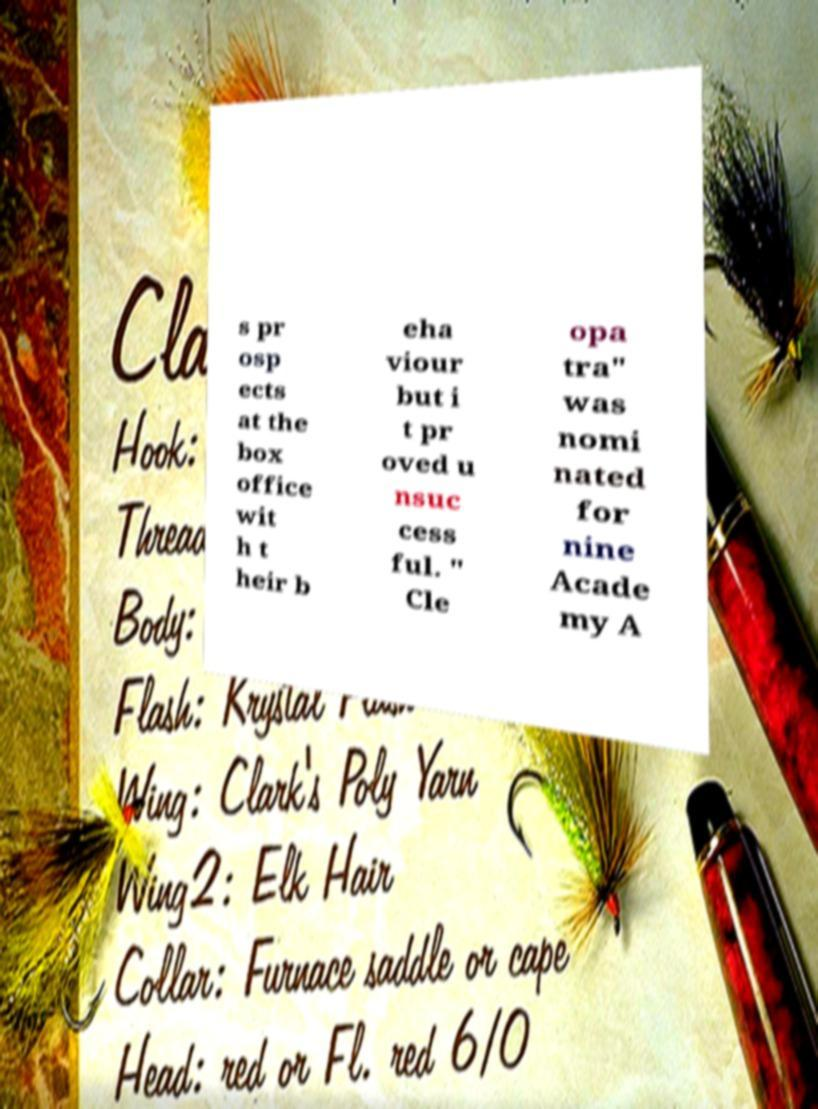Please read and relay the text visible in this image. What does it say? s pr osp ects at the box office wit h t heir b eha viour but i t pr oved u nsuc cess ful. " Cle opa tra" was nomi nated for nine Acade my A 